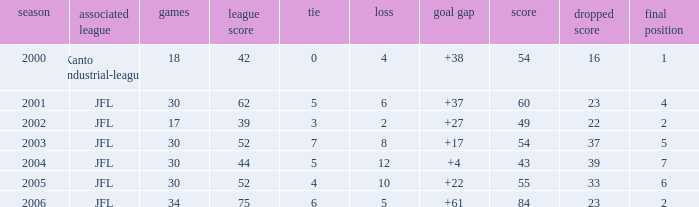I want the average lose for lost point more than 16 and goal difference less than 37 and point less than 43 None. 